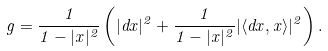<formula> <loc_0><loc_0><loc_500><loc_500>g = \frac { 1 } { 1 - | { x } | ^ { 2 } } \left ( | d { x } | ^ { 2 } + \frac { 1 } { 1 - | { x } | ^ { 2 } } | \langle d { x } , { x } \rangle | ^ { 2 } \right ) .</formula> 